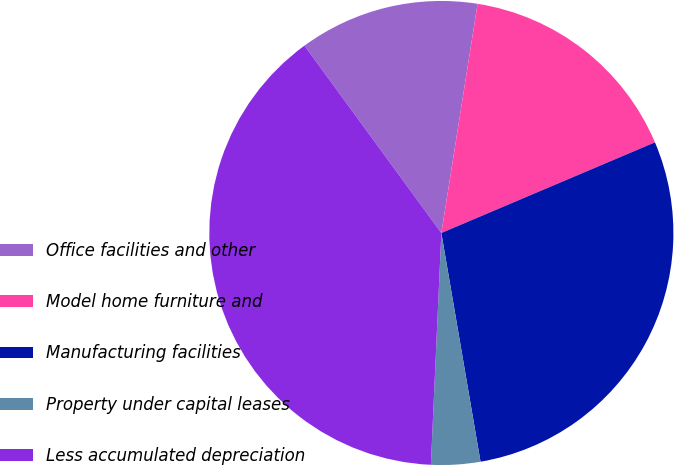<chart> <loc_0><loc_0><loc_500><loc_500><pie_chart><fcel>Office facilities and other<fcel>Model home furniture and<fcel>Manufacturing facilities<fcel>Property under capital leases<fcel>Less accumulated depreciation<nl><fcel>12.54%<fcel>16.12%<fcel>28.69%<fcel>3.42%<fcel>39.24%<nl></chart> 